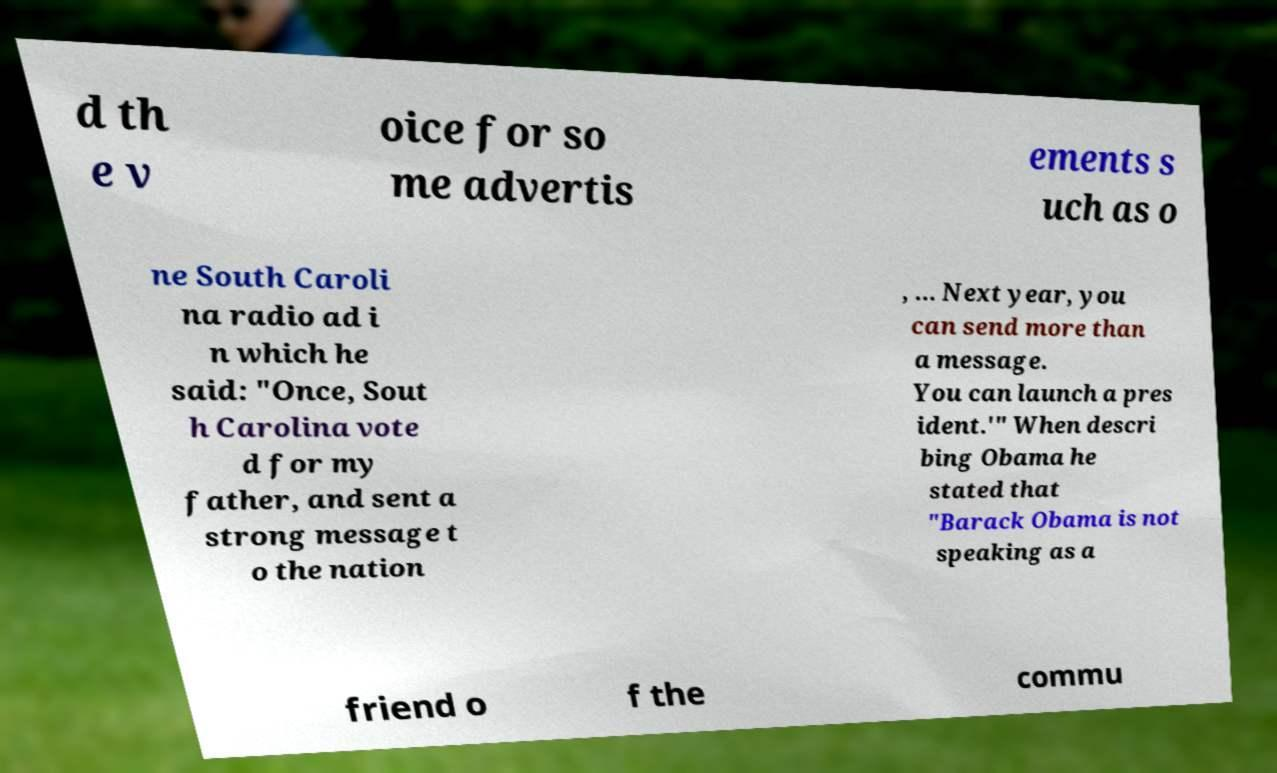There's text embedded in this image that I need extracted. Can you transcribe it verbatim? d th e v oice for so me advertis ements s uch as o ne South Caroli na radio ad i n which he said: "Once, Sout h Carolina vote d for my father, and sent a strong message t o the nation , ... Next year, you can send more than a message. You can launch a pres ident.'" When descri bing Obama he stated that "Barack Obama is not speaking as a friend o f the commu 